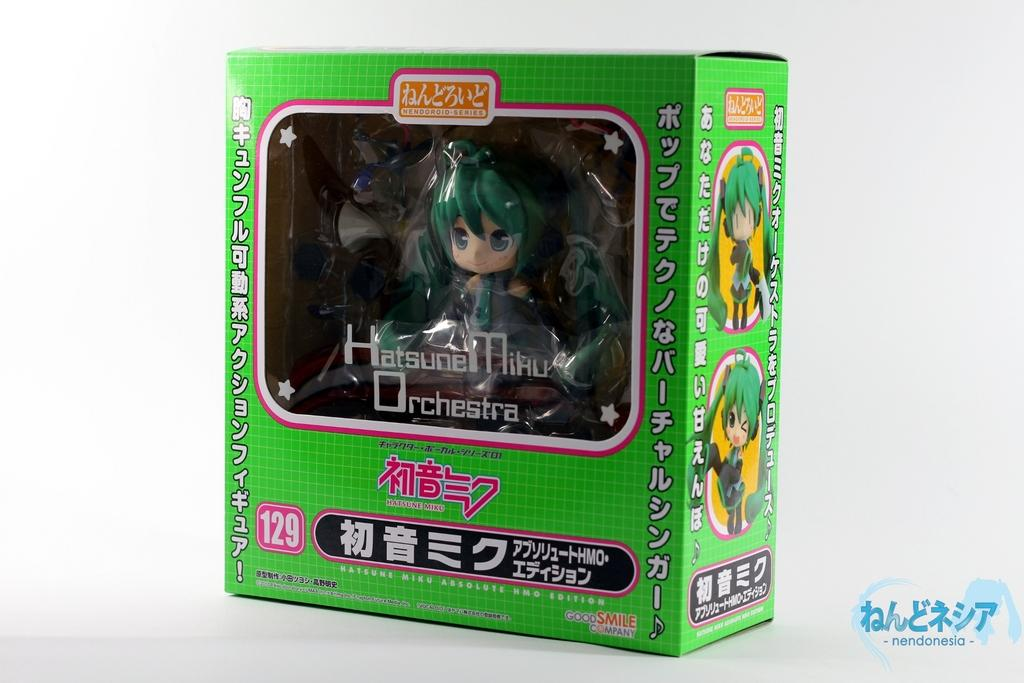What object is placed on the floor in the image? There is a box on the floor in the image. What color is the background of the image? The background of the image is white. What can be seen in addition to the box on the floor? There is text visible in the image. Where might this image have been taken? The image is likely taken in a room, given the presence of a white background and the box on the floor. What level of difficulty is the box on the floor in the image? The image does not provide information about the difficulty level of the box on the floor. --- 